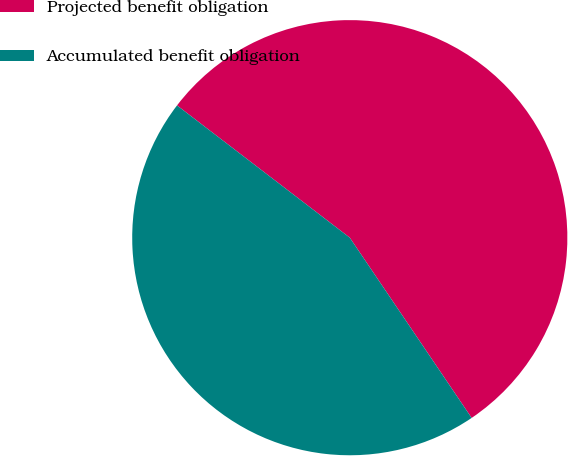<chart> <loc_0><loc_0><loc_500><loc_500><pie_chart><fcel>Projected benefit obligation<fcel>Accumulated benefit obligation<nl><fcel>55.14%<fcel>44.86%<nl></chart> 